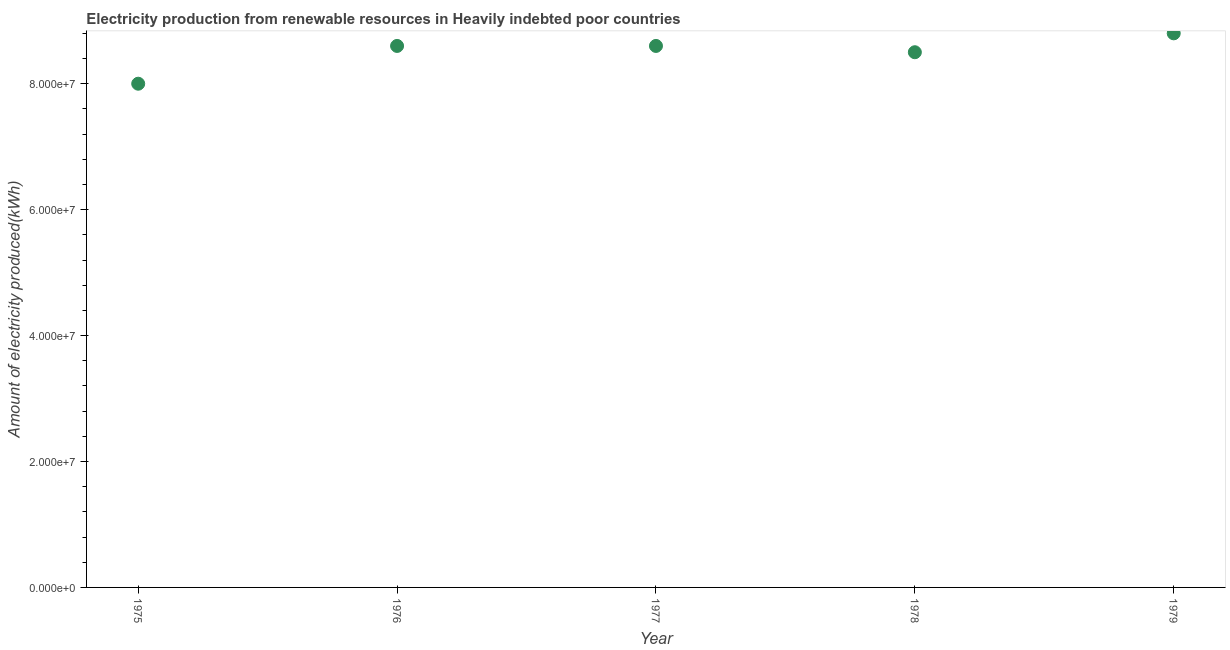What is the amount of electricity produced in 1979?
Provide a succinct answer. 8.80e+07. Across all years, what is the maximum amount of electricity produced?
Give a very brief answer. 8.80e+07. Across all years, what is the minimum amount of electricity produced?
Make the answer very short. 8.00e+07. In which year was the amount of electricity produced maximum?
Your response must be concise. 1979. In which year was the amount of electricity produced minimum?
Provide a short and direct response. 1975. What is the sum of the amount of electricity produced?
Ensure brevity in your answer.  4.25e+08. What is the difference between the amount of electricity produced in 1975 and 1976?
Provide a succinct answer. -6.00e+06. What is the average amount of electricity produced per year?
Offer a terse response. 8.50e+07. What is the median amount of electricity produced?
Offer a terse response. 8.60e+07. In how many years, is the amount of electricity produced greater than 16000000 kWh?
Make the answer very short. 5. Do a majority of the years between 1978 and 1979 (inclusive) have amount of electricity produced greater than 84000000 kWh?
Your response must be concise. Yes. What is the ratio of the amount of electricity produced in 1976 to that in 1978?
Offer a terse response. 1.01. Is the difference between the amount of electricity produced in 1975 and 1976 greater than the difference between any two years?
Give a very brief answer. No. What is the difference between the highest and the second highest amount of electricity produced?
Make the answer very short. 2.00e+06. Is the sum of the amount of electricity produced in 1976 and 1978 greater than the maximum amount of electricity produced across all years?
Provide a short and direct response. Yes. What is the difference between the highest and the lowest amount of electricity produced?
Your answer should be very brief. 8.00e+06. In how many years, is the amount of electricity produced greater than the average amount of electricity produced taken over all years?
Make the answer very short. 3. Does the amount of electricity produced monotonically increase over the years?
Provide a short and direct response. No. How many dotlines are there?
Provide a succinct answer. 1. Are the values on the major ticks of Y-axis written in scientific E-notation?
Provide a short and direct response. Yes. Does the graph contain grids?
Your response must be concise. No. What is the title of the graph?
Make the answer very short. Electricity production from renewable resources in Heavily indebted poor countries. What is the label or title of the X-axis?
Offer a terse response. Year. What is the label or title of the Y-axis?
Provide a succinct answer. Amount of electricity produced(kWh). What is the Amount of electricity produced(kWh) in 1975?
Provide a short and direct response. 8.00e+07. What is the Amount of electricity produced(kWh) in 1976?
Your answer should be very brief. 8.60e+07. What is the Amount of electricity produced(kWh) in 1977?
Ensure brevity in your answer.  8.60e+07. What is the Amount of electricity produced(kWh) in 1978?
Offer a very short reply. 8.50e+07. What is the Amount of electricity produced(kWh) in 1979?
Your answer should be compact. 8.80e+07. What is the difference between the Amount of electricity produced(kWh) in 1975 and 1976?
Your answer should be very brief. -6.00e+06. What is the difference between the Amount of electricity produced(kWh) in 1975 and 1977?
Offer a very short reply. -6.00e+06. What is the difference between the Amount of electricity produced(kWh) in 1975 and 1978?
Ensure brevity in your answer.  -5.00e+06. What is the difference between the Amount of electricity produced(kWh) in 1975 and 1979?
Offer a very short reply. -8.00e+06. What is the difference between the Amount of electricity produced(kWh) in 1976 and 1978?
Offer a terse response. 1.00e+06. What is the difference between the Amount of electricity produced(kWh) in 1976 and 1979?
Offer a very short reply. -2.00e+06. What is the ratio of the Amount of electricity produced(kWh) in 1975 to that in 1976?
Provide a succinct answer. 0.93. What is the ratio of the Amount of electricity produced(kWh) in 1975 to that in 1978?
Ensure brevity in your answer.  0.94. What is the ratio of the Amount of electricity produced(kWh) in 1975 to that in 1979?
Your response must be concise. 0.91. What is the ratio of the Amount of electricity produced(kWh) in 1976 to that in 1977?
Provide a succinct answer. 1. What is the ratio of the Amount of electricity produced(kWh) in 1976 to that in 1979?
Give a very brief answer. 0.98. What is the ratio of the Amount of electricity produced(kWh) in 1978 to that in 1979?
Ensure brevity in your answer.  0.97. 